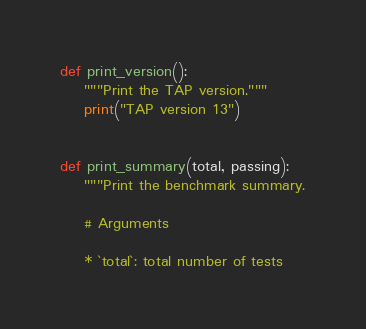<code> <loc_0><loc_0><loc_500><loc_500><_Python_>

def print_version():
    """Print the TAP version."""
    print("TAP version 13")


def print_summary(total, passing):
    """Print the benchmark summary.

    # Arguments

    * `total`: total number of tests</code> 